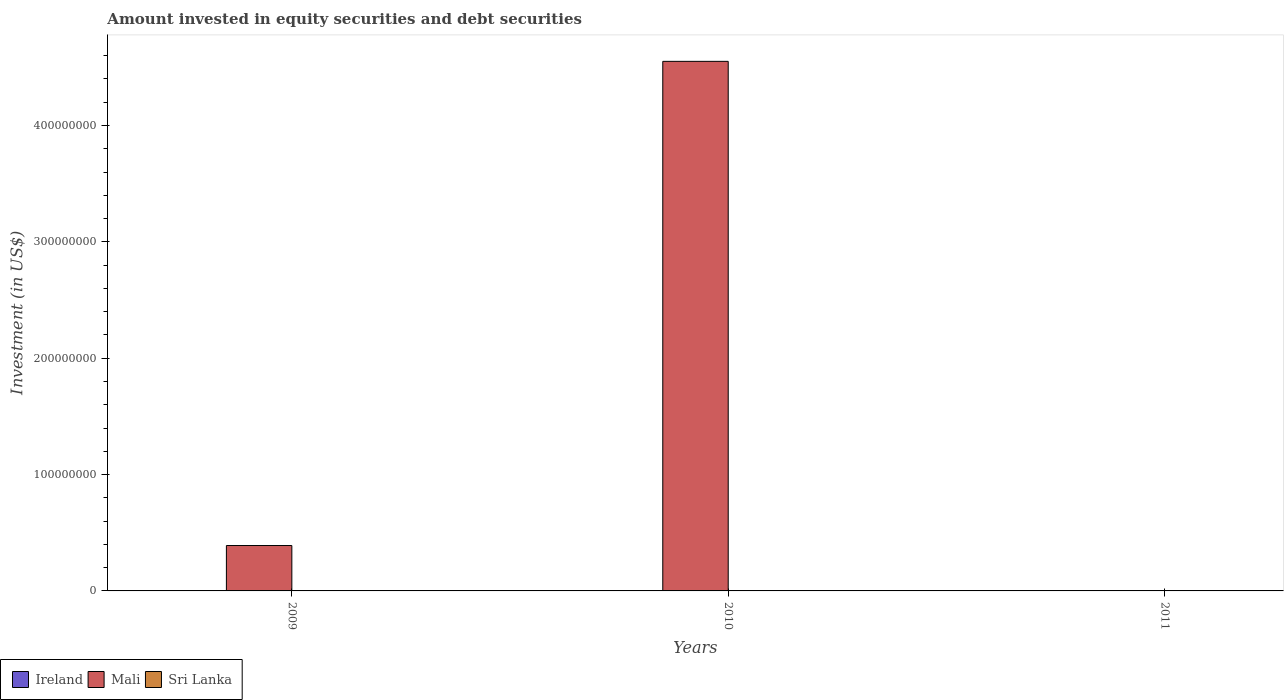How many different coloured bars are there?
Offer a terse response. 1. Are the number of bars per tick equal to the number of legend labels?
Your answer should be very brief. No. Are the number of bars on each tick of the X-axis equal?
Your answer should be very brief. No. How many bars are there on the 3rd tick from the right?
Provide a short and direct response. 1. What is the amount invested in equity securities and debt securities in Ireland in 2011?
Offer a very short reply. 0. Across all years, what is the maximum amount invested in equity securities and debt securities in Mali?
Provide a short and direct response. 4.55e+08. Across all years, what is the minimum amount invested in equity securities and debt securities in Ireland?
Make the answer very short. 0. What is the total amount invested in equity securities and debt securities in Mali in the graph?
Provide a succinct answer. 4.94e+08. What is the difference between the amount invested in equity securities and debt securities in Mali in 2009 and that in 2010?
Provide a short and direct response. -4.16e+08. What is the difference between the amount invested in equity securities and debt securities in Ireland in 2011 and the amount invested in equity securities and debt securities in Mali in 2010?
Provide a succinct answer. -4.55e+08. What is the average amount invested in equity securities and debt securities in Mali per year?
Make the answer very short. 1.65e+08. In how many years, is the amount invested in equity securities and debt securities in Ireland greater than 380000000 US$?
Ensure brevity in your answer.  0. What is the ratio of the amount invested in equity securities and debt securities in Mali in 2009 to that in 2010?
Make the answer very short. 0.09. Is the amount invested in equity securities and debt securities in Mali in 2009 less than that in 2010?
Give a very brief answer. Yes. What is the difference between the highest and the lowest amount invested in equity securities and debt securities in Mali?
Provide a succinct answer. 4.55e+08. Is the sum of the amount invested in equity securities and debt securities in Mali in 2009 and 2010 greater than the maximum amount invested in equity securities and debt securities in Sri Lanka across all years?
Give a very brief answer. Yes. How many bars are there?
Your response must be concise. 2. Are the values on the major ticks of Y-axis written in scientific E-notation?
Give a very brief answer. No. Does the graph contain any zero values?
Provide a short and direct response. Yes. What is the title of the graph?
Ensure brevity in your answer.  Amount invested in equity securities and debt securities. Does "Colombia" appear as one of the legend labels in the graph?
Ensure brevity in your answer.  No. What is the label or title of the X-axis?
Your response must be concise. Years. What is the label or title of the Y-axis?
Offer a very short reply. Investment (in US$). What is the Investment (in US$) in Mali in 2009?
Offer a terse response. 3.90e+07. What is the Investment (in US$) in Mali in 2010?
Offer a terse response. 4.55e+08. What is the Investment (in US$) in Sri Lanka in 2010?
Keep it short and to the point. 0. What is the Investment (in US$) in Ireland in 2011?
Offer a terse response. 0. Across all years, what is the maximum Investment (in US$) of Mali?
Offer a terse response. 4.55e+08. What is the total Investment (in US$) in Ireland in the graph?
Make the answer very short. 0. What is the total Investment (in US$) in Mali in the graph?
Give a very brief answer. 4.94e+08. What is the difference between the Investment (in US$) of Mali in 2009 and that in 2010?
Ensure brevity in your answer.  -4.16e+08. What is the average Investment (in US$) in Ireland per year?
Ensure brevity in your answer.  0. What is the average Investment (in US$) of Mali per year?
Provide a succinct answer. 1.65e+08. What is the ratio of the Investment (in US$) in Mali in 2009 to that in 2010?
Your answer should be very brief. 0.09. What is the difference between the highest and the lowest Investment (in US$) in Mali?
Ensure brevity in your answer.  4.55e+08. 